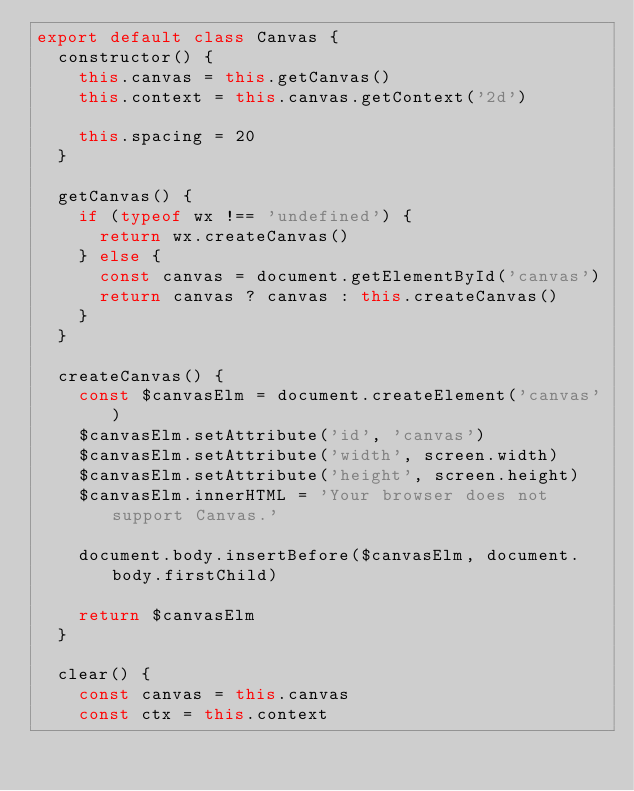Convert code to text. <code><loc_0><loc_0><loc_500><loc_500><_JavaScript_>export default class Canvas {
  constructor() {
    this.canvas = this.getCanvas()
    this.context = this.canvas.getContext('2d')

    this.spacing = 20
  }

  getCanvas() {
    if (typeof wx !== 'undefined') {
      return wx.createCanvas()
    } else {
      const canvas = document.getElementById('canvas')
      return canvas ? canvas : this.createCanvas()
    }
  }

  createCanvas() {
    const $canvasElm = document.createElement('canvas')
    $canvasElm.setAttribute('id', 'canvas')
    $canvasElm.setAttribute('width', screen.width)
    $canvasElm.setAttribute('height', screen.height)
    $canvasElm.innerHTML = 'Your browser does not support Canvas.'

    document.body.insertBefore($canvasElm, document.body.firstChild)

    return $canvasElm
  }

  clear() {
    const canvas = this.canvas
    const ctx = this.context
</code> 